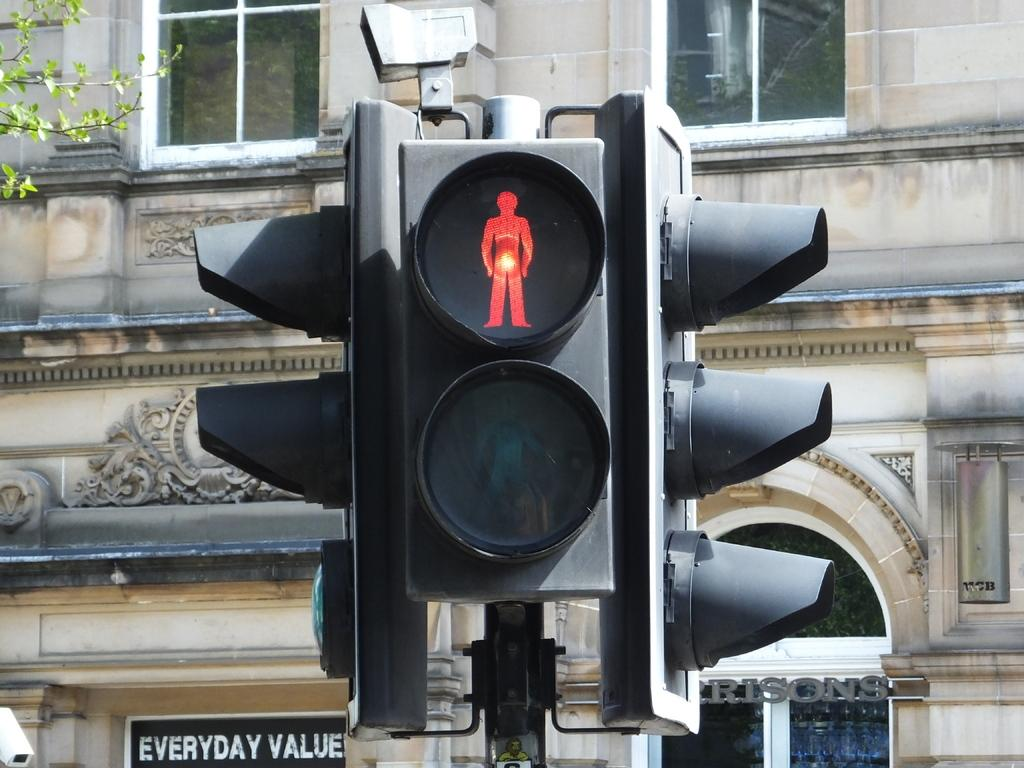<image>
Provide a brief description of the given image. A traffic light that has its stop signal on for passengers waiting near an everyday value sign. 